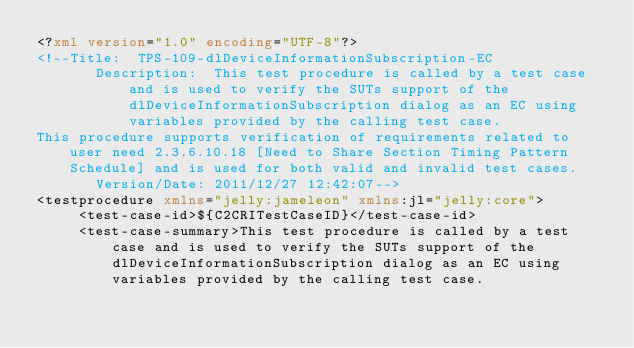Convert code to text. <code><loc_0><loc_0><loc_500><loc_500><_XML_><?xml version="1.0" encoding="UTF-8"?>
<!--Title:  TPS-109-dlDeviceInformationSubscription-EC
       Description:  This test procedure is called by a test case and is used to verify the SUTs support of the dlDeviceInformationSubscription dialog as an EC using variables provided by the calling test case.  
This procedure supports verification of requirements related to user need 2.3.6.10.18 [Need to Share Section Timing Pattern Schedule] and is used for both valid and invalid test cases.
       Version/Date: 2011/12/27 12:42:07-->
<testprocedure xmlns="jelly:jameleon" xmlns:jl="jelly:core">
     <test-case-id>${C2CRITestCaseID}</test-case-id>
     <test-case-summary>This test procedure is called by a test case and is used to verify the SUTs support of the dlDeviceInformationSubscription dialog as an EC using variables provided by the calling test case.  </code> 